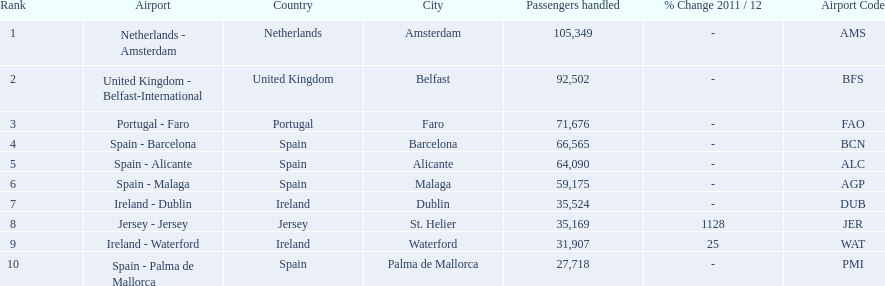What are the airports? Netherlands - Amsterdam, United Kingdom - Belfast-International, Portugal - Faro, Spain - Barcelona, Spain - Alicante, Spain - Malaga, Ireland - Dublin, Jersey - Jersey, Ireland - Waterford, Spain - Palma de Mallorca. Of these which has the least amount of passengers? Spain - Palma de Mallorca. 